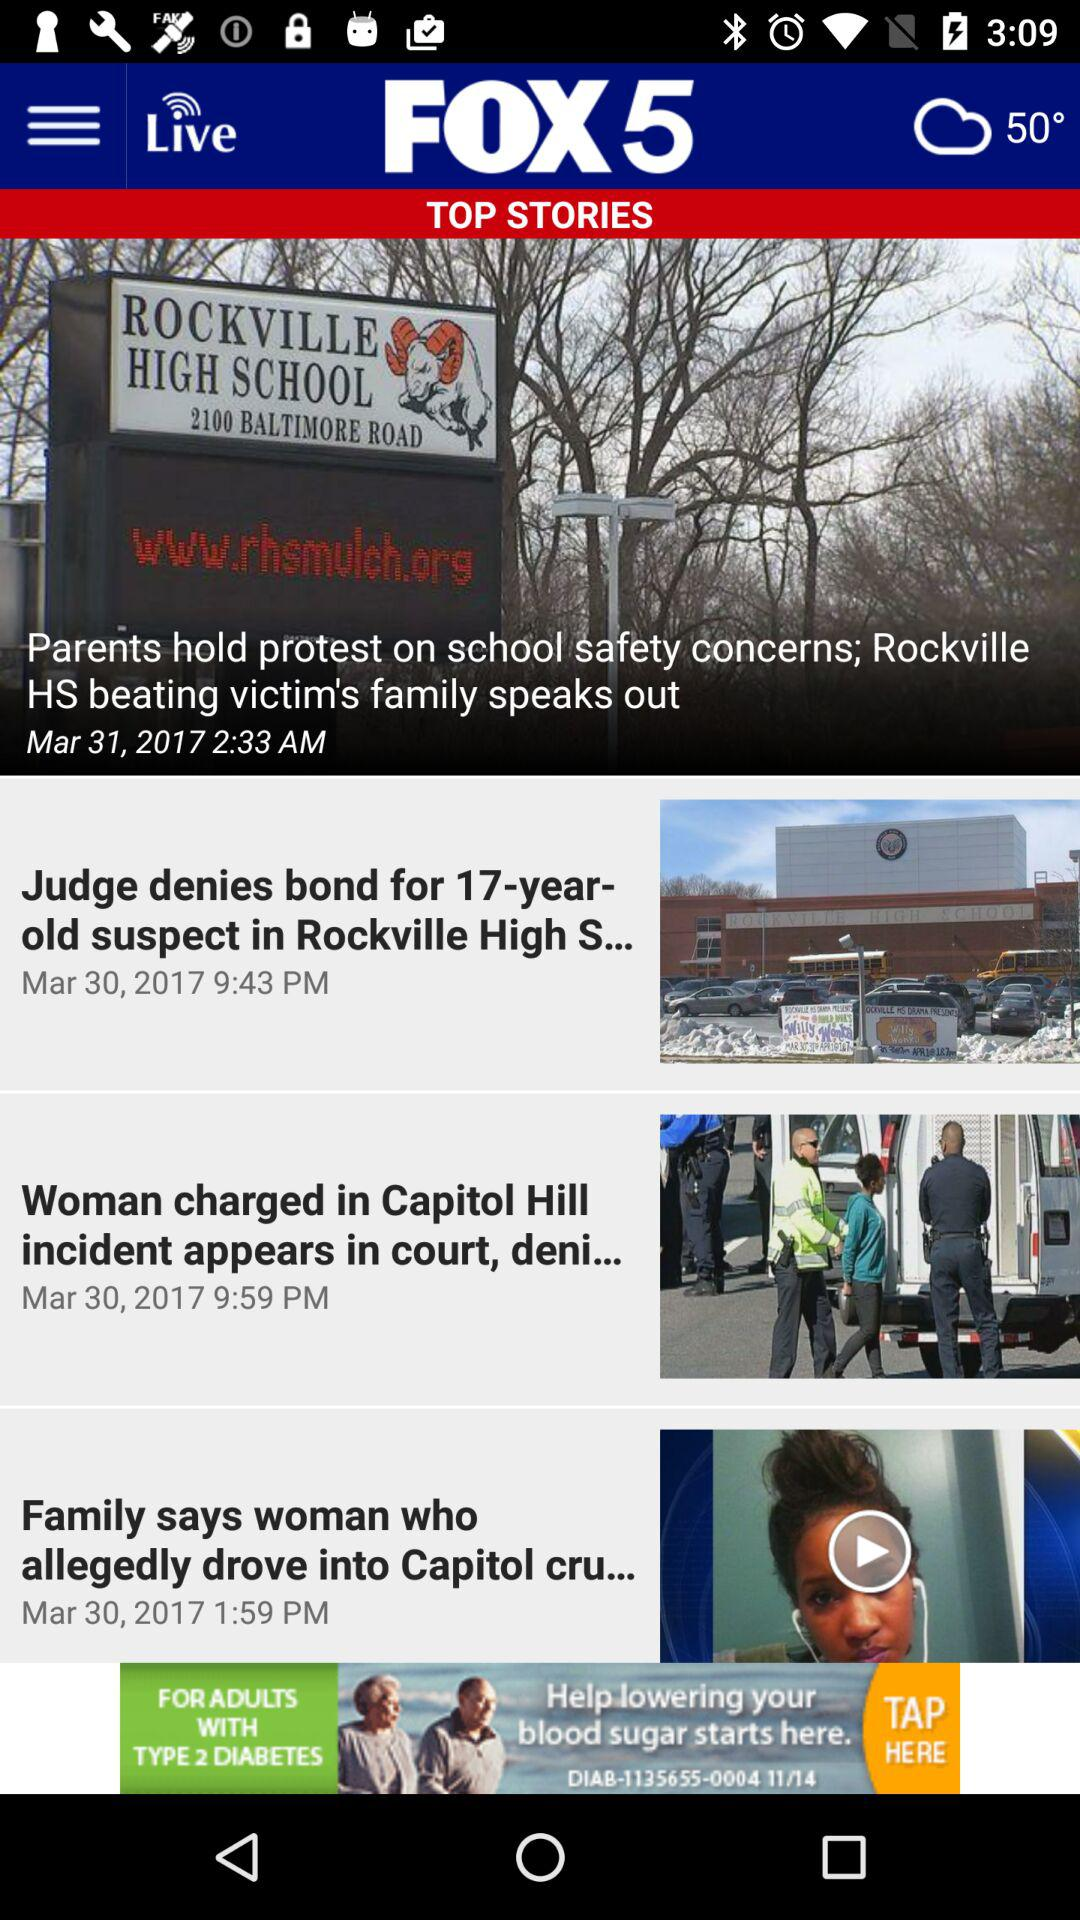At what date was the news about the "Woman charged in Capitol Hill incident appears in court" posted? The news about the "Woman charged in Capitol Hill incident appears in court" was posted on March 30, 2017. 